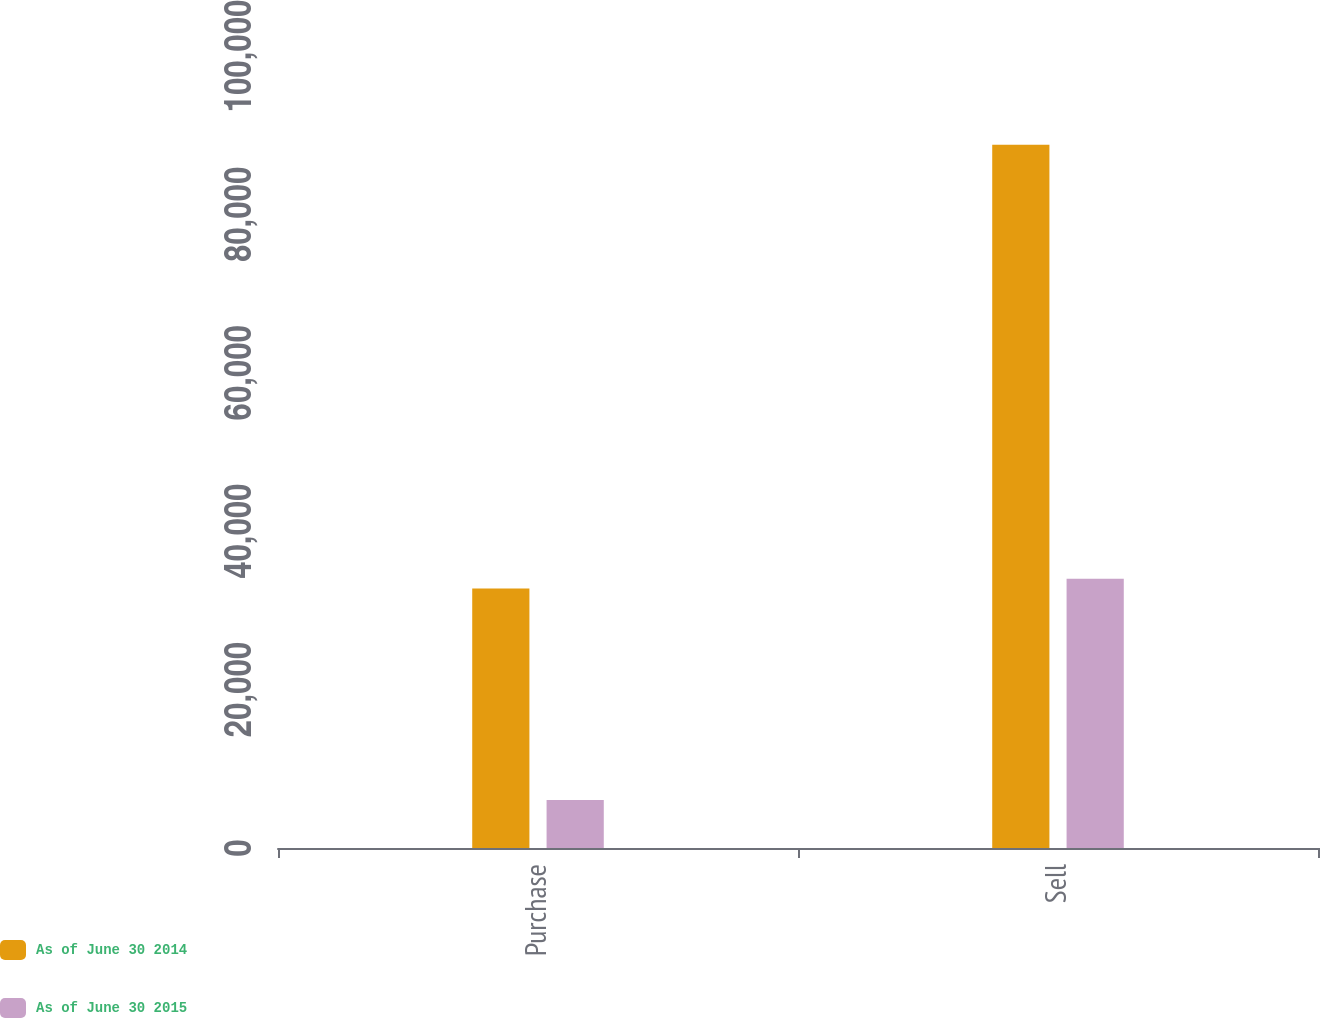<chart> <loc_0><loc_0><loc_500><loc_500><stacked_bar_chart><ecel><fcel>Purchase<fcel>Sell<nl><fcel>As of June 30 2014<fcel>32775<fcel>88800<nl><fcel>As of June 30 2015<fcel>6066<fcel>33999<nl></chart> 